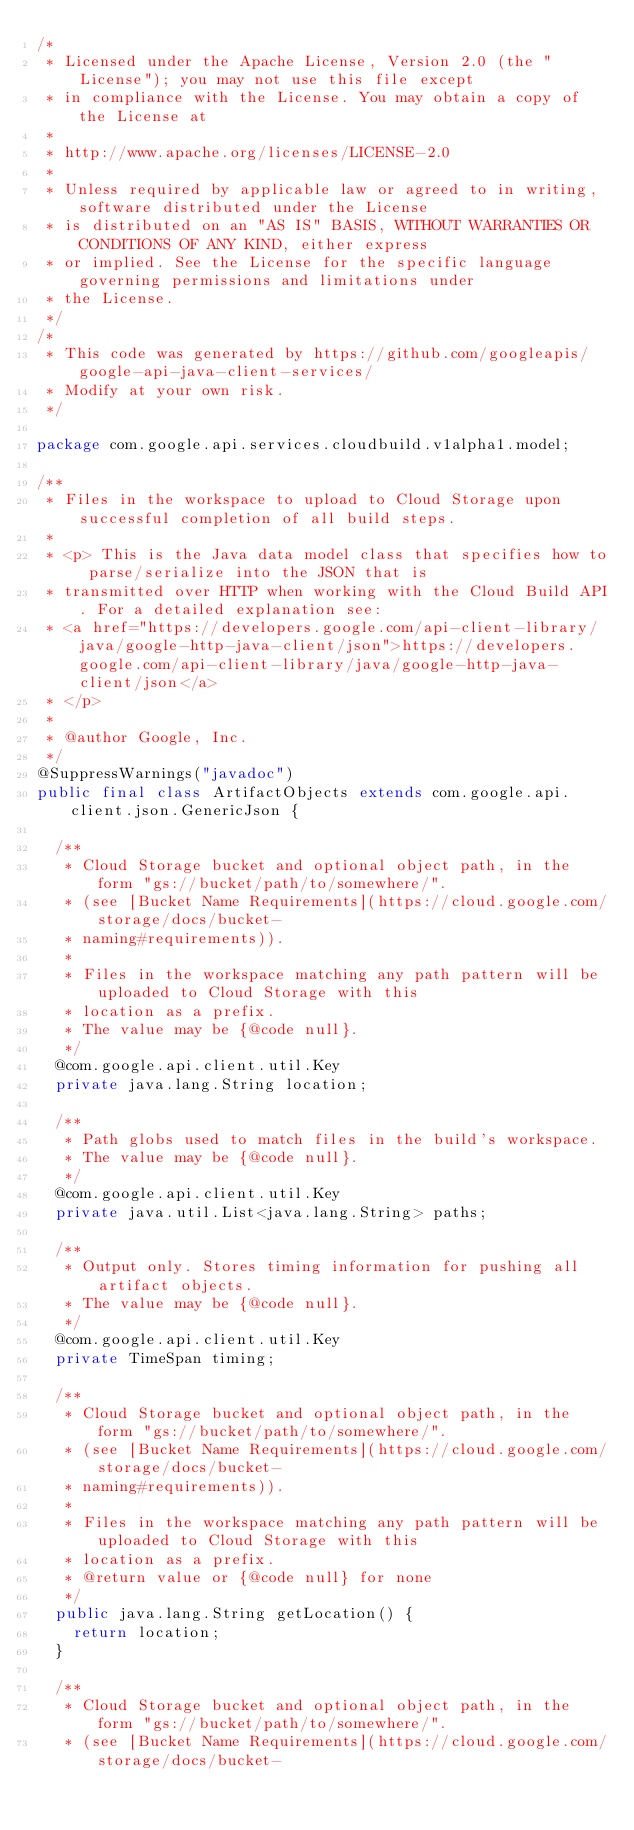<code> <loc_0><loc_0><loc_500><loc_500><_Java_>/*
 * Licensed under the Apache License, Version 2.0 (the "License"); you may not use this file except
 * in compliance with the License. You may obtain a copy of the License at
 *
 * http://www.apache.org/licenses/LICENSE-2.0
 *
 * Unless required by applicable law or agreed to in writing, software distributed under the License
 * is distributed on an "AS IS" BASIS, WITHOUT WARRANTIES OR CONDITIONS OF ANY KIND, either express
 * or implied. See the License for the specific language governing permissions and limitations under
 * the License.
 */
/*
 * This code was generated by https://github.com/googleapis/google-api-java-client-services/
 * Modify at your own risk.
 */

package com.google.api.services.cloudbuild.v1alpha1.model;

/**
 * Files in the workspace to upload to Cloud Storage upon successful completion of all build steps.
 *
 * <p> This is the Java data model class that specifies how to parse/serialize into the JSON that is
 * transmitted over HTTP when working with the Cloud Build API. For a detailed explanation see:
 * <a href="https://developers.google.com/api-client-library/java/google-http-java-client/json">https://developers.google.com/api-client-library/java/google-http-java-client/json</a>
 * </p>
 *
 * @author Google, Inc.
 */
@SuppressWarnings("javadoc")
public final class ArtifactObjects extends com.google.api.client.json.GenericJson {

  /**
   * Cloud Storage bucket and optional object path, in the form "gs://bucket/path/to/somewhere/".
   * (see [Bucket Name Requirements](https://cloud.google.com/storage/docs/bucket-
   * naming#requirements)).
   *
   * Files in the workspace matching any path pattern will be uploaded to Cloud Storage with this
   * location as a prefix.
   * The value may be {@code null}.
   */
  @com.google.api.client.util.Key
  private java.lang.String location;

  /**
   * Path globs used to match files in the build's workspace.
   * The value may be {@code null}.
   */
  @com.google.api.client.util.Key
  private java.util.List<java.lang.String> paths;

  /**
   * Output only. Stores timing information for pushing all artifact objects.
   * The value may be {@code null}.
   */
  @com.google.api.client.util.Key
  private TimeSpan timing;

  /**
   * Cloud Storage bucket and optional object path, in the form "gs://bucket/path/to/somewhere/".
   * (see [Bucket Name Requirements](https://cloud.google.com/storage/docs/bucket-
   * naming#requirements)).
   *
   * Files in the workspace matching any path pattern will be uploaded to Cloud Storage with this
   * location as a prefix.
   * @return value or {@code null} for none
   */
  public java.lang.String getLocation() {
    return location;
  }

  /**
   * Cloud Storage bucket and optional object path, in the form "gs://bucket/path/to/somewhere/".
   * (see [Bucket Name Requirements](https://cloud.google.com/storage/docs/bucket-</code> 